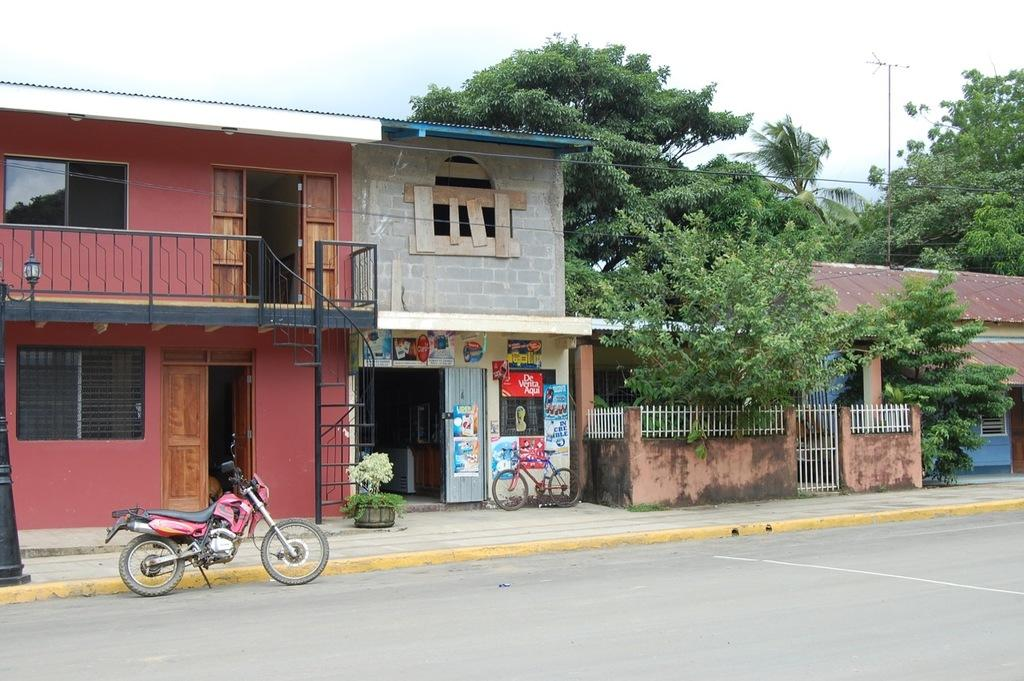What type of pathway is present in the image? There is a road in the image. What mode of transportation can be seen in the image? There is a red and black motorbike in the image. What is the surface next to the road used for? The sidewalk is visible in the image. What type of vegetation is present in the image? There are trees in the image. What type of structures are visible in the image? There are buildings in the image. What other mode of transportation can be seen in the image? There is a bicycle in the image. What can be seen in the background of the image? The sky is visible in the background of the image. What type of paste is being used to repair the roof in the image? There is no roof or paste present in the image. What type of work is being done on the bicycle in the image? There is no indication of any work being done on the bicycle in the image. 